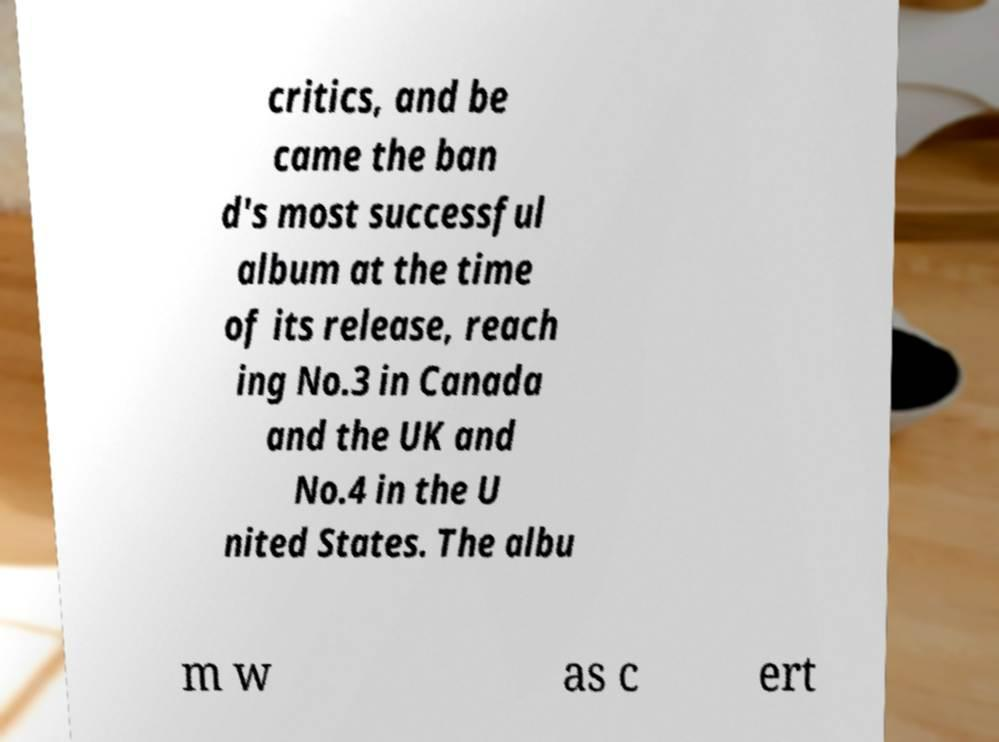Could you extract and type out the text from this image? critics, and be came the ban d's most successful album at the time of its release, reach ing No.3 in Canada and the UK and No.4 in the U nited States. The albu m w as c ert 